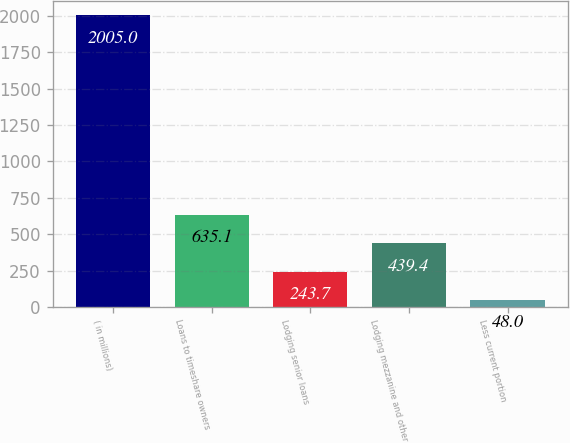Convert chart to OTSL. <chart><loc_0><loc_0><loc_500><loc_500><bar_chart><fcel>( in millions)<fcel>Loans to timeshare owners<fcel>Lodging senior loans<fcel>Lodging mezzanine and other<fcel>Less current portion<nl><fcel>2005<fcel>635.1<fcel>243.7<fcel>439.4<fcel>48<nl></chart> 